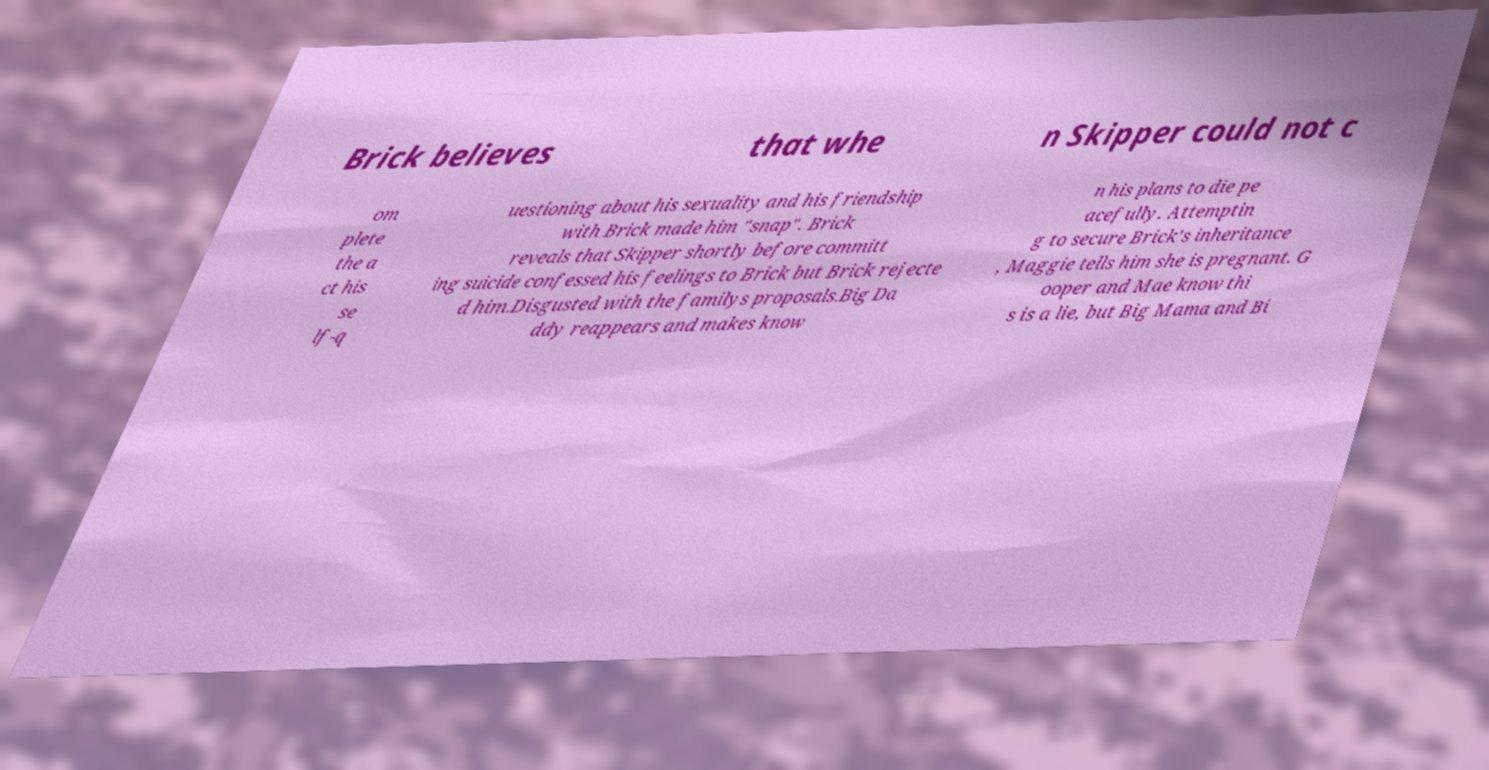For documentation purposes, I need the text within this image transcribed. Could you provide that? Brick believes that whe n Skipper could not c om plete the a ct his se lf-q uestioning about his sexuality and his friendship with Brick made him "snap". Brick reveals that Skipper shortly before committ ing suicide confessed his feelings to Brick but Brick rejecte d him.Disgusted with the familys proposals.Big Da ddy reappears and makes know n his plans to die pe acefully. Attemptin g to secure Brick's inheritance , Maggie tells him she is pregnant. G ooper and Mae know thi s is a lie, but Big Mama and Bi 